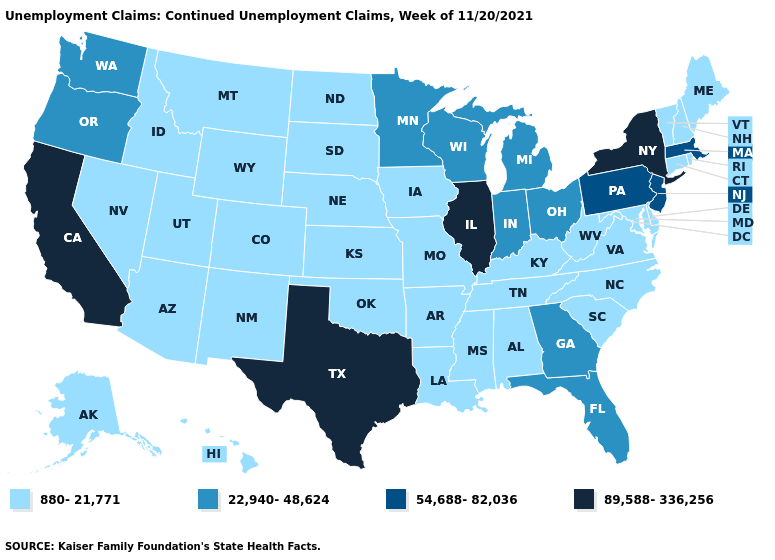Name the states that have a value in the range 54,688-82,036?
Answer briefly. Massachusetts, New Jersey, Pennsylvania. Which states have the highest value in the USA?
Answer briefly. California, Illinois, New York, Texas. What is the value of Wisconsin?
Quick response, please. 22,940-48,624. Does Ohio have the highest value in the MidWest?
Be succinct. No. Is the legend a continuous bar?
Write a very short answer. No. Name the states that have a value in the range 89,588-336,256?
Keep it brief. California, Illinois, New York, Texas. Name the states that have a value in the range 89,588-336,256?
Concise answer only. California, Illinois, New York, Texas. What is the lowest value in the USA?
Be succinct. 880-21,771. Among the states that border New Hampshire , which have the highest value?
Write a very short answer. Massachusetts. Name the states that have a value in the range 89,588-336,256?
Quick response, please. California, Illinois, New York, Texas. Name the states that have a value in the range 22,940-48,624?
Give a very brief answer. Florida, Georgia, Indiana, Michigan, Minnesota, Ohio, Oregon, Washington, Wisconsin. Does Illinois have the highest value in the MidWest?
Concise answer only. Yes. Does Oregon have the lowest value in the USA?
Quick response, please. No. Does New Hampshire have a higher value than Nebraska?
Answer briefly. No. What is the lowest value in the Northeast?
Keep it brief. 880-21,771. 